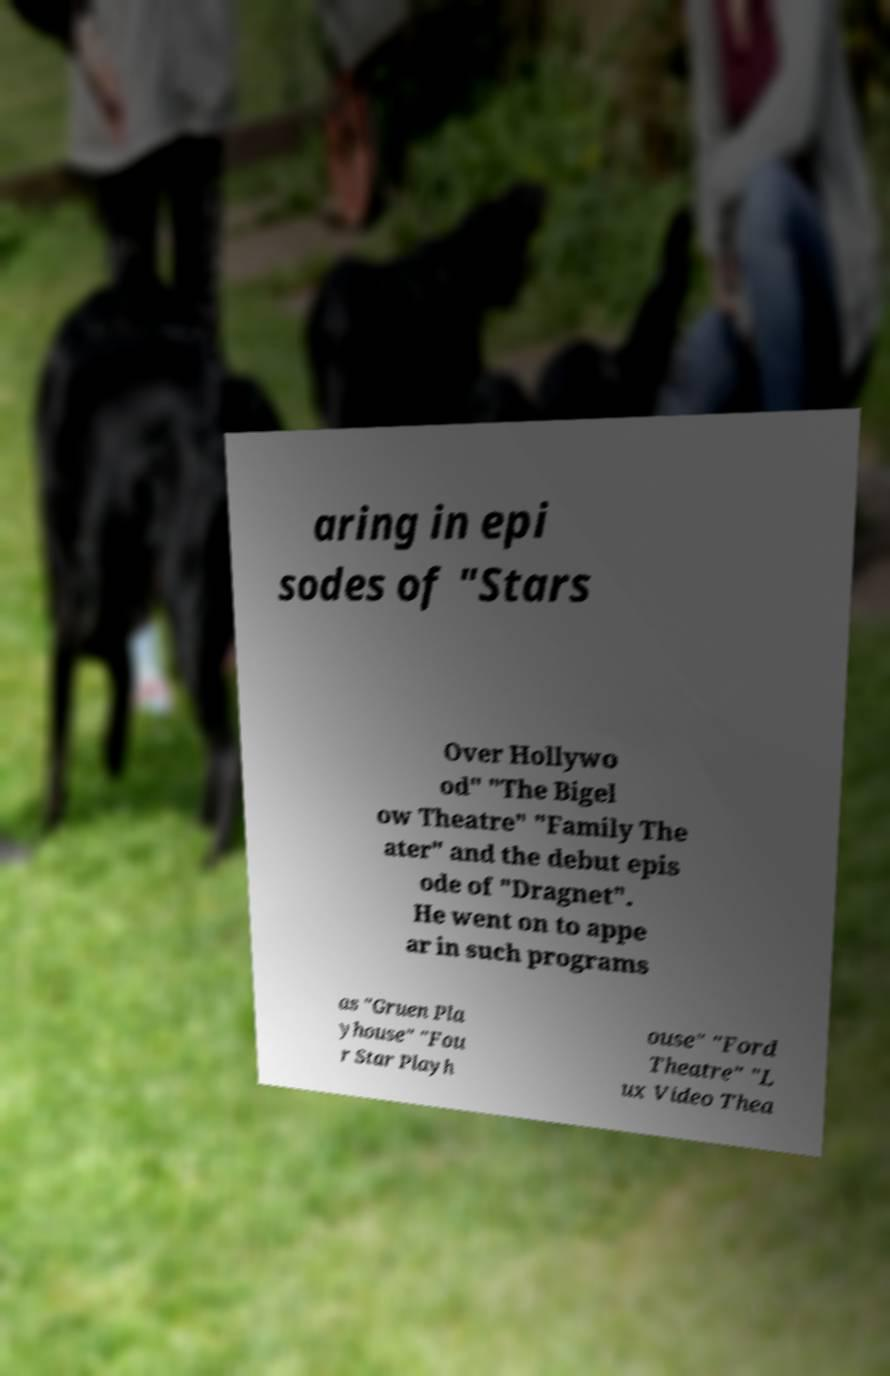Can you read and provide the text displayed in the image?This photo seems to have some interesting text. Can you extract and type it out for me? aring in epi sodes of "Stars Over Hollywo od" "The Bigel ow Theatre" "Family The ater" and the debut epis ode of "Dragnet". He went on to appe ar in such programs as "Gruen Pla yhouse" "Fou r Star Playh ouse" "Ford Theatre" "L ux Video Thea 